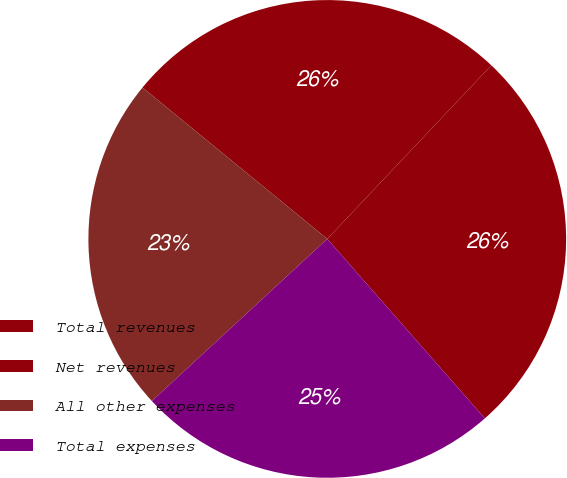<chart> <loc_0><loc_0><loc_500><loc_500><pie_chart><fcel>Total revenues<fcel>Net revenues<fcel>All other expenses<fcel>Total expenses<nl><fcel>26.48%<fcel>26.13%<fcel>22.8%<fcel>24.59%<nl></chart> 